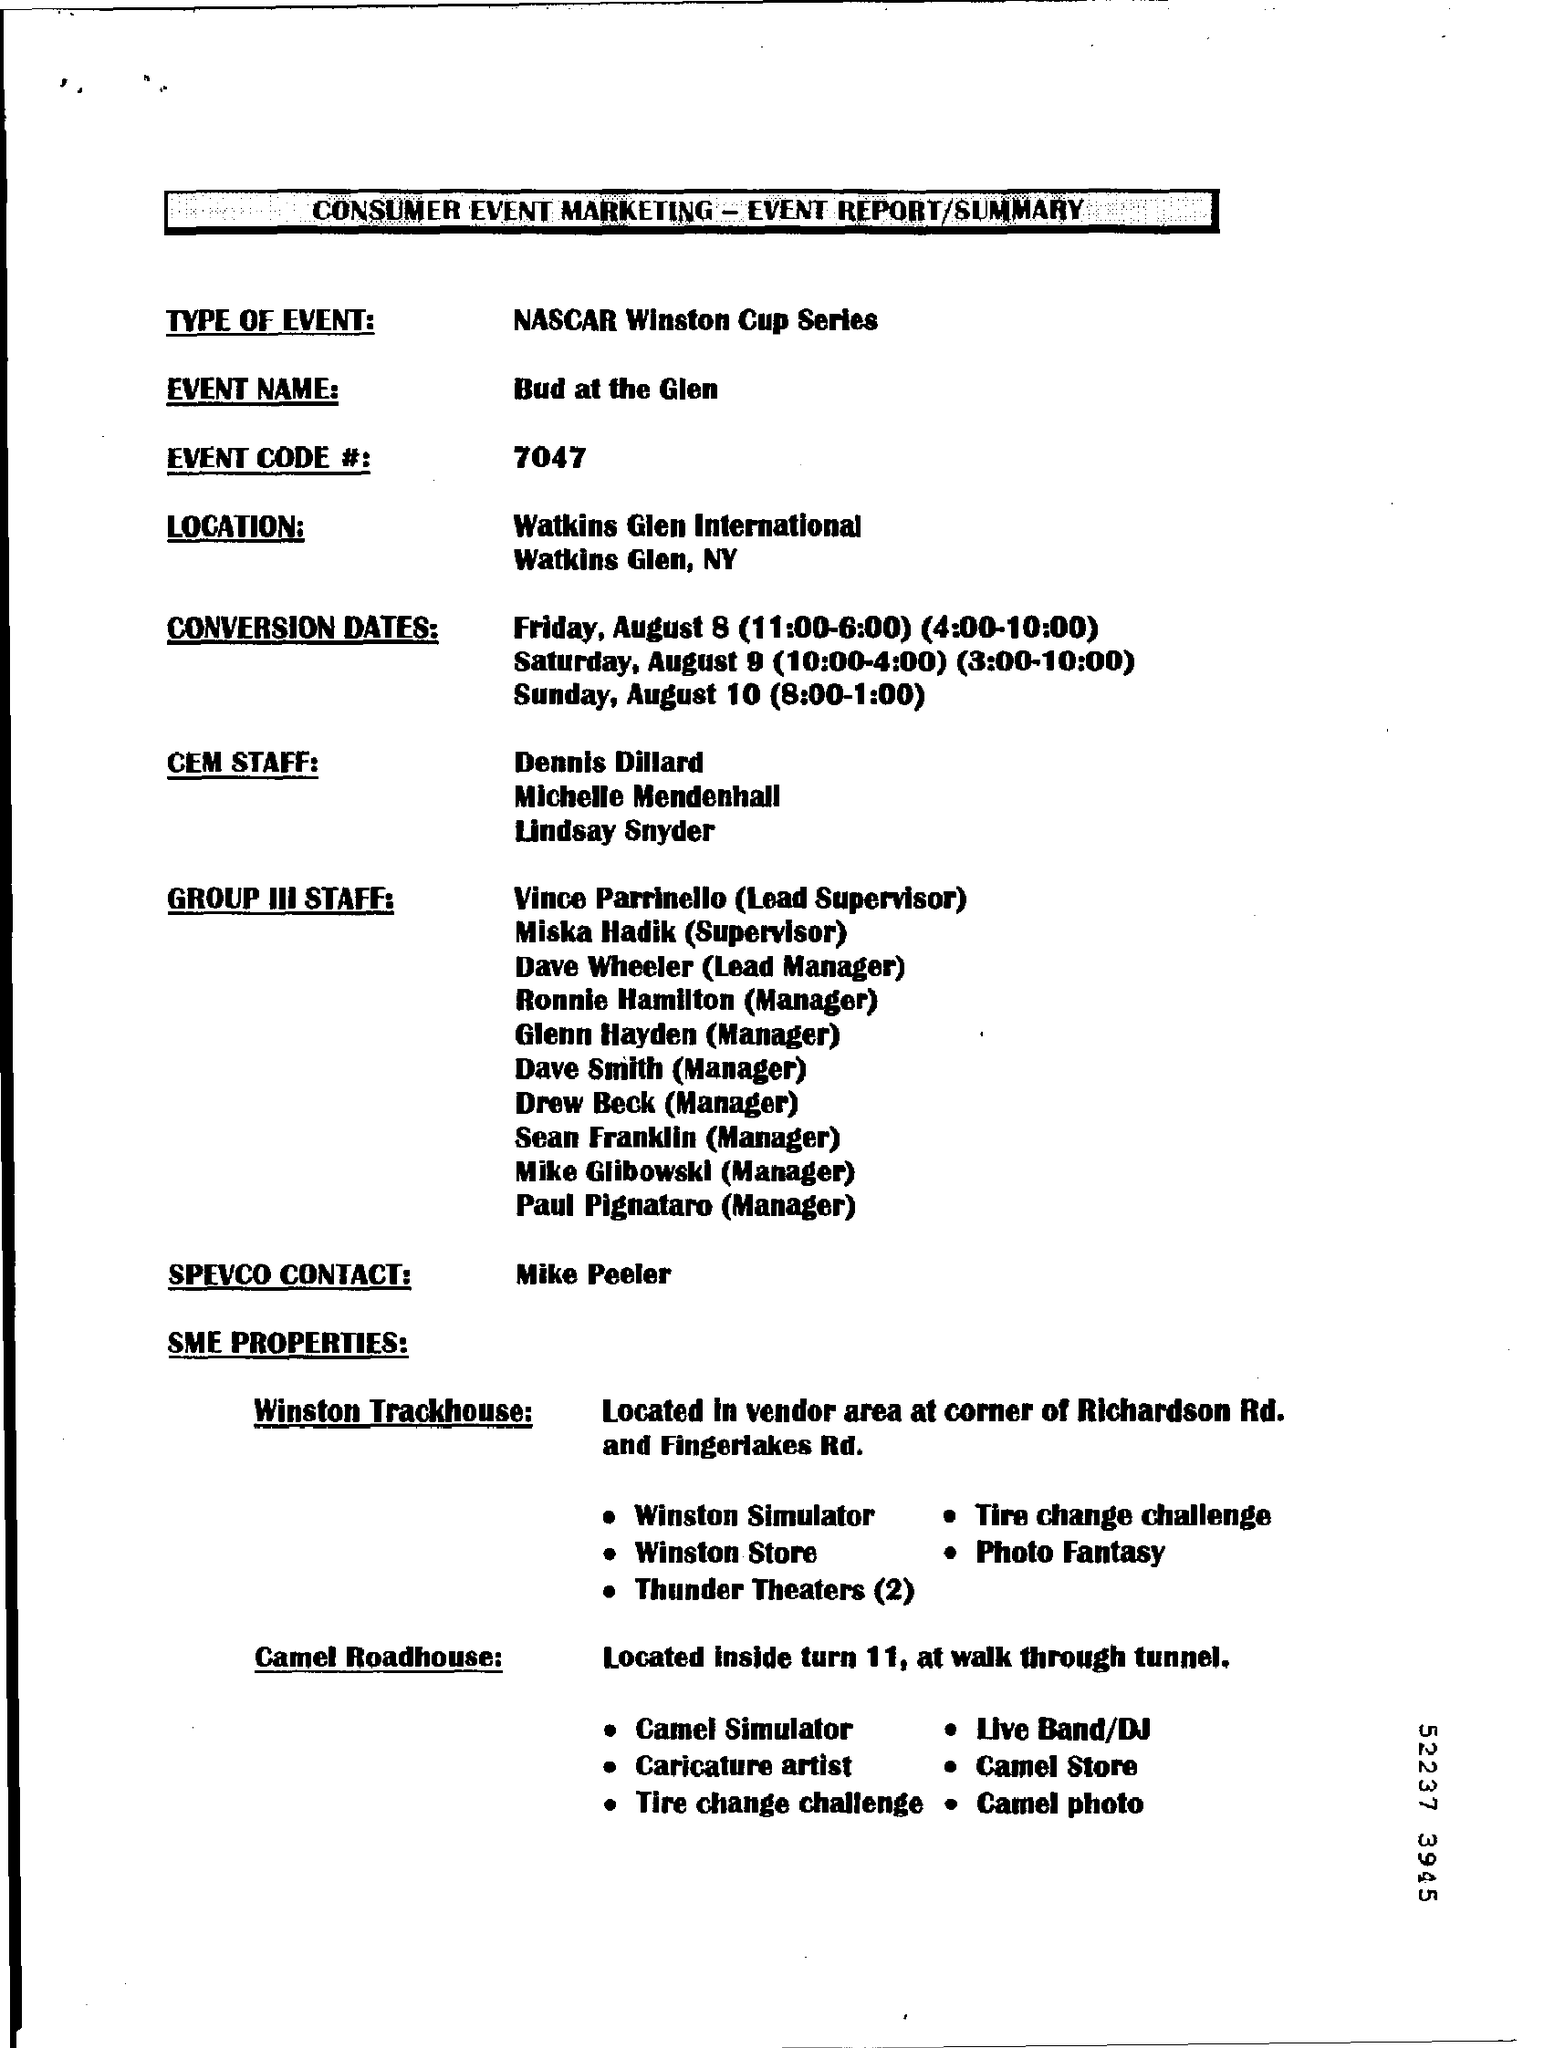What is the Type of Event?
Offer a terse response. NASCAR Winston Cup Series. What is the Event name?
Your answer should be very brief. Bud at the Glen. What is the Event Code #?
Give a very brief answer. 7047. Who is the spevco contact?
Ensure brevity in your answer.  Mike Peeler. What is located inside Turn 11, at walk through tunnel?
Your answer should be very brief. Camel Roadhouse. 